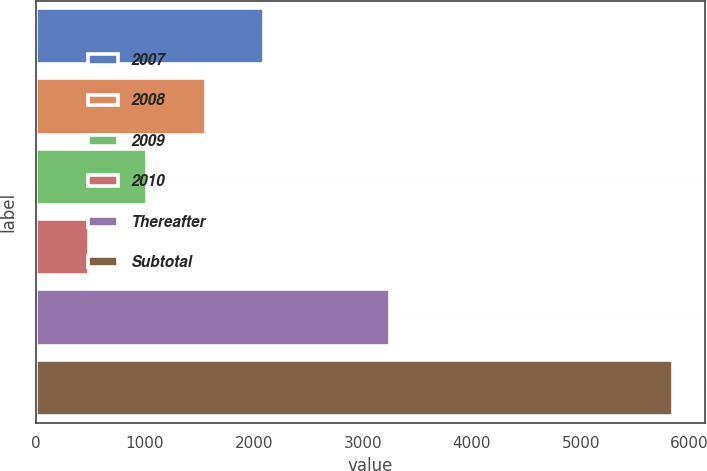<chart> <loc_0><loc_0><loc_500><loc_500><bar_chart><fcel>2007<fcel>2008<fcel>2009<fcel>2010<fcel>Thereafter<fcel>Subtotal<nl><fcel>2095.2<fcel>1558.8<fcel>1022.4<fcel>486<fcel>3247<fcel>5850<nl></chart> 